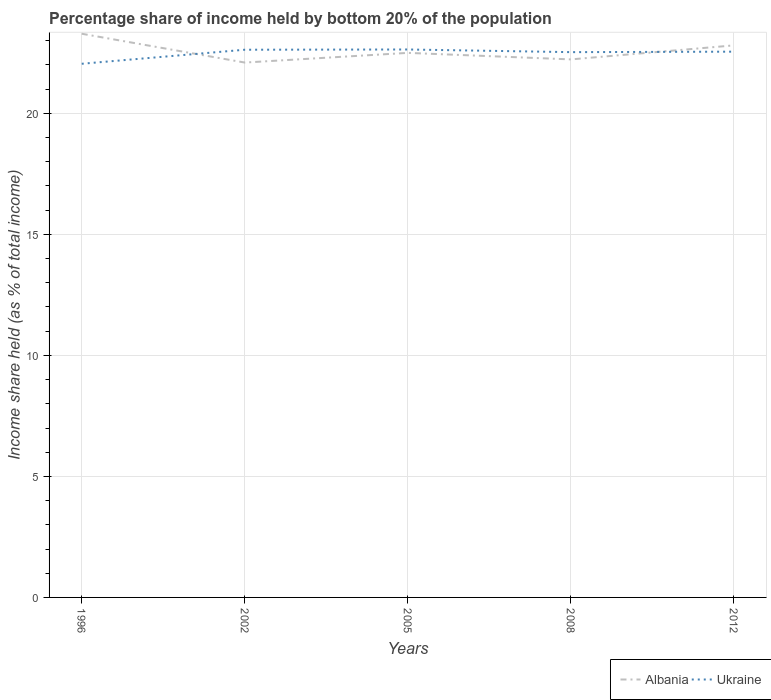Does the line corresponding to Ukraine intersect with the line corresponding to Albania?
Make the answer very short. Yes. Is the number of lines equal to the number of legend labels?
Keep it short and to the point. Yes. Across all years, what is the maximum share of income held by bottom 20% of the population in Ukraine?
Your answer should be very brief. 22.05. What is the total share of income held by bottom 20% of the population in Ukraine in the graph?
Keep it short and to the point. 0.08. What is the difference between the highest and the second highest share of income held by bottom 20% of the population in Albania?
Offer a terse response. 1.19. What is the difference between the highest and the lowest share of income held by bottom 20% of the population in Albania?
Provide a short and direct response. 2. Are the values on the major ticks of Y-axis written in scientific E-notation?
Your response must be concise. No. Does the graph contain grids?
Provide a succinct answer. Yes. Where does the legend appear in the graph?
Offer a terse response. Bottom right. What is the title of the graph?
Ensure brevity in your answer.  Percentage share of income held by bottom 20% of the population. Does "Cambodia" appear as one of the legend labels in the graph?
Provide a succinct answer. No. What is the label or title of the Y-axis?
Keep it short and to the point. Income share held (as % of total income). What is the Income share held (as % of total income) in Albania in 1996?
Provide a short and direct response. 23.29. What is the Income share held (as % of total income) in Ukraine in 1996?
Offer a terse response. 22.05. What is the Income share held (as % of total income) of Albania in 2002?
Ensure brevity in your answer.  22.1. What is the Income share held (as % of total income) of Ukraine in 2002?
Provide a short and direct response. 22.63. What is the Income share held (as % of total income) of Ukraine in 2005?
Your response must be concise. 22.64. What is the Income share held (as % of total income) in Albania in 2008?
Give a very brief answer. 22.23. What is the Income share held (as % of total income) of Ukraine in 2008?
Make the answer very short. 22.53. What is the Income share held (as % of total income) of Albania in 2012?
Your response must be concise. 22.81. What is the Income share held (as % of total income) in Ukraine in 2012?
Give a very brief answer. 22.55. Across all years, what is the maximum Income share held (as % of total income) in Albania?
Your response must be concise. 23.29. Across all years, what is the maximum Income share held (as % of total income) of Ukraine?
Ensure brevity in your answer.  22.64. Across all years, what is the minimum Income share held (as % of total income) of Albania?
Offer a very short reply. 22.1. Across all years, what is the minimum Income share held (as % of total income) of Ukraine?
Make the answer very short. 22.05. What is the total Income share held (as % of total income) of Albania in the graph?
Your answer should be compact. 112.93. What is the total Income share held (as % of total income) of Ukraine in the graph?
Provide a short and direct response. 112.4. What is the difference between the Income share held (as % of total income) of Albania in 1996 and that in 2002?
Give a very brief answer. 1.19. What is the difference between the Income share held (as % of total income) of Ukraine in 1996 and that in 2002?
Provide a short and direct response. -0.58. What is the difference between the Income share held (as % of total income) in Albania in 1996 and that in 2005?
Offer a terse response. 0.79. What is the difference between the Income share held (as % of total income) of Ukraine in 1996 and that in 2005?
Offer a terse response. -0.59. What is the difference between the Income share held (as % of total income) in Albania in 1996 and that in 2008?
Your response must be concise. 1.06. What is the difference between the Income share held (as % of total income) of Ukraine in 1996 and that in 2008?
Provide a short and direct response. -0.48. What is the difference between the Income share held (as % of total income) in Albania in 1996 and that in 2012?
Offer a very short reply. 0.48. What is the difference between the Income share held (as % of total income) in Ukraine in 2002 and that in 2005?
Provide a short and direct response. -0.01. What is the difference between the Income share held (as % of total income) of Albania in 2002 and that in 2008?
Your answer should be compact. -0.13. What is the difference between the Income share held (as % of total income) of Albania in 2002 and that in 2012?
Provide a short and direct response. -0.71. What is the difference between the Income share held (as % of total income) of Albania in 2005 and that in 2008?
Offer a very short reply. 0.27. What is the difference between the Income share held (as % of total income) of Ukraine in 2005 and that in 2008?
Provide a short and direct response. 0.11. What is the difference between the Income share held (as % of total income) in Albania in 2005 and that in 2012?
Make the answer very short. -0.31. What is the difference between the Income share held (as % of total income) of Ukraine in 2005 and that in 2012?
Offer a terse response. 0.09. What is the difference between the Income share held (as % of total income) in Albania in 2008 and that in 2012?
Give a very brief answer. -0.58. What is the difference between the Income share held (as % of total income) in Ukraine in 2008 and that in 2012?
Keep it short and to the point. -0.02. What is the difference between the Income share held (as % of total income) in Albania in 1996 and the Income share held (as % of total income) in Ukraine in 2002?
Your answer should be compact. 0.66. What is the difference between the Income share held (as % of total income) in Albania in 1996 and the Income share held (as % of total income) in Ukraine in 2005?
Your response must be concise. 0.65. What is the difference between the Income share held (as % of total income) in Albania in 1996 and the Income share held (as % of total income) in Ukraine in 2008?
Your answer should be compact. 0.76. What is the difference between the Income share held (as % of total income) of Albania in 1996 and the Income share held (as % of total income) of Ukraine in 2012?
Offer a terse response. 0.74. What is the difference between the Income share held (as % of total income) of Albania in 2002 and the Income share held (as % of total income) of Ukraine in 2005?
Make the answer very short. -0.54. What is the difference between the Income share held (as % of total income) of Albania in 2002 and the Income share held (as % of total income) of Ukraine in 2008?
Provide a short and direct response. -0.43. What is the difference between the Income share held (as % of total income) of Albania in 2002 and the Income share held (as % of total income) of Ukraine in 2012?
Your response must be concise. -0.45. What is the difference between the Income share held (as % of total income) in Albania in 2005 and the Income share held (as % of total income) in Ukraine in 2008?
Give a very brief answer. -0.03. What is the difference between the Income share held (as % of total income) of Albania in 2005 and the Income share held (as % of total income) of Ukraine in 2012?
Keep it short and to the point. -0.05. What is the difference between the Income share held (as % of total income) of Albania in 2008 and the Income share held (as % of total income) of Ukraine in 2012?
Ensure brevity in your answer.  -0.32. What is the average Income share held (as % of total income) of Albania per year?
Keep it short and to the point. 22.59. What is the average Income share held (as % of total income) of Ukraine per year?
Your answer should be very brief. 22.48. In the year 1996, what is the difference between the Income share held (as % of total income) in Albania and Income share held (as % of total income) in Ukraine?
Ensure brevity in your answer.  1.24. In the year 2002, what is the difference between the Income share held (as % of total income) in Albania and Income share held (as % of total income) in Ukraine?
Provide a short and direct response. -0.53. In the year 2005, what is the difference between the Income share held (as % of total income) of Albania and Income share held (as % of total income) of Ukraine?
Keep it short and to the point. -0.14. In the year 2008, what is the difference between the Income share held (as % of total income) in Albania and Income share held (as % of total income) in Ukraine?
Give a very brief answer. -0.3. In the year 2012, what is the difference between the Income share held (as % of total income) in Albania and Income share held (as % of total income) in Ukraine?
Make the answer very short. 0.26. What is the ratio of the Income share held (as % of total income) in Albania in 1996 to that in 2002?
Give a very brief answer. 1.05. What is the ratio of the Income share held (as % of total income) of Ukraine in 1996 to that in 2002?
Provide a short and direct response. 0.97. What is the ratio of the Income share held (as % of total income) in Albania in 1996 to that in 2005?
Keep it short and to the point. 1.04. What is the ratio of the Income share held (as % of total income) of Ukraine in 1996 to that in 2005?
Offer a very short reply. 0.97. What is the ratio of the Income share held (as % of total income) of Albania in 1996 to that in 2008?
Your answer should be compact. 1.05. What is the ratio of the Income share held (as % of total income) of Ukraine in 1996 to that in 2008?
Your answer should be very brief. 0.98. What is the ratio of the Income share held (as % of total income) of Ukraine in 1996 to that in 2012?
Ensure brevity in your answer.  0.98. What is the ratio of the Income share held (as % of total income) of Albania in 2002 to that in 2005?
Your answer should be very brief. 0.98. What is the ratio of the Income share held (as % of total income) of Ukraine in 2002 to that in 2005?
Give a very brief answer. 1. What is the ratio of the Income share held (as % of total income) of Albania in 2002 to that in 2008?
Your answer should be compact. 0.99. What is the ratio of the Income share held (as % of total income) in Ukraine in 2002 to that in 2008?
Your response must be concise. 1. What is the ratio of the Income share held (as % of total income) of Albania in 2002 to that in 2012?
Make the answer very short. 0.97. What is the ratio of the Income share held (as % of total income) of Ukraine in 2002 to that in 2012?
Your answer should be compact. 1. What is the ratio of the Income share held (as % of total income) of Albania in 2005 to that in 2008?
Provide a succinct answer. 1.01. What is the ratio of the Income share held (as % of total income) of Albania in 2005 to that in 2012?
Make the answer very short. 0.99. What is the ratio of the Income share held (as % of total income) in Albania in 2008 to that in 2012?
Give a very brief answer. 0.97. What is the ratio of the Income share held (as % of total income) in Ukraine in 2008 to that in 2012?
Give a very brief answer. 1. What is the difference between the highest and the second highest Income share held (as % of total income) in Albania?
Your answer should be very brief. 0.48. What is the difference between the highest and the second highest Income share held (as % of total income) in Ukraine?
Your response must be concise. 0.01. What is the difference between the highest and the lowest Income share held (as % of total income) of Albania?
Provide a short and direct response. 1.19. What is the difference between the highest and the lowest Income share held (as % of total income) in Ukraine?
Offer a terse response. 0.59. 